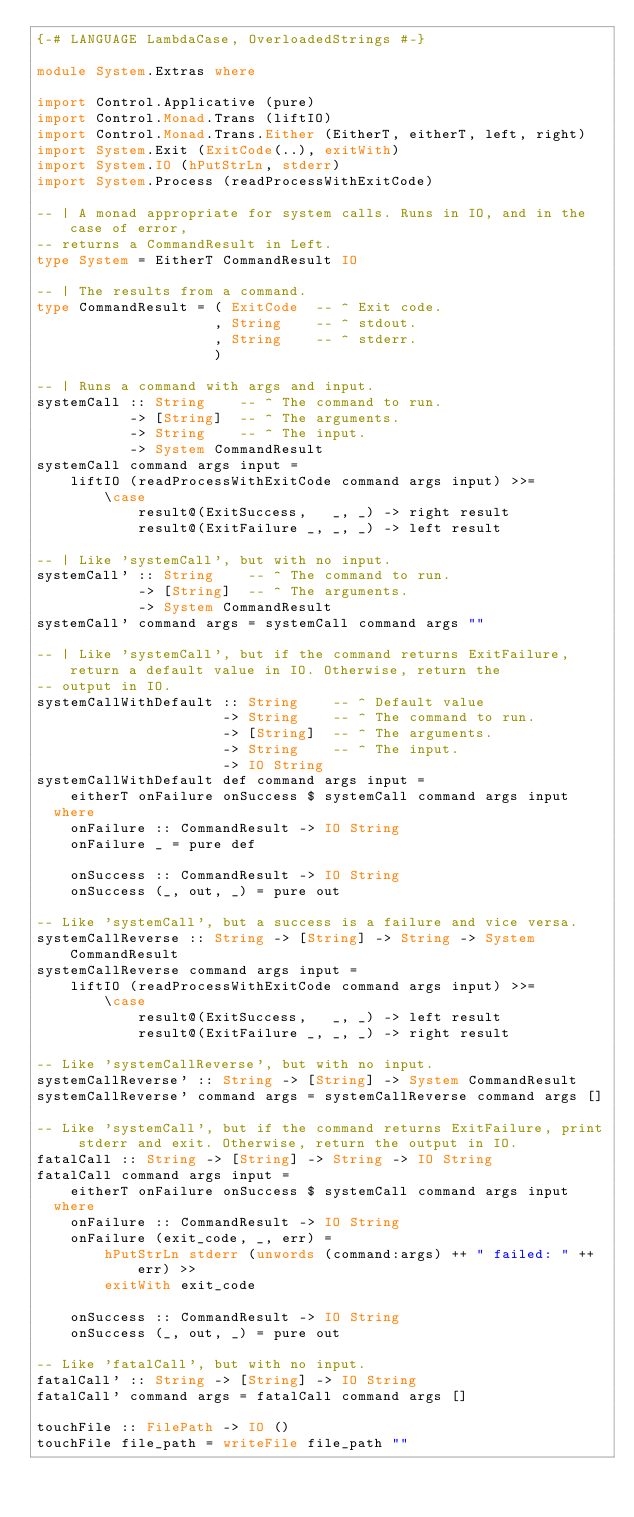<code> <loc_0><loc_0><loc_500><loc_500><_Haskell_>{-# LANGUAGE LambdaCase, OverloadedStrings #-}

module System.Extras where

import Control.Applicative (pure)
import Control.Monad.Trans (liftIO)
import Control.Monad.Trans.Either (EitherT, eitherT, left, right)
import System.Exit (ExitCode(..), exitWith)
import System.IO (hPutStrLn, stderr)
import System.Process (readProcessWithExitCode)

-- | A monad appropriate for system calls. Runs in IO, and in the case of error,
-- returns a CommandResult in Left.
type System = EitherT CommandResult IO

-- | The results from a command.
type CommandResult = ( ExitCode  -- ^ Exit code.
                     , String    -- ^ stdout.
                     , String    -- ^ stderr.
                     )

-- | Runs a command with args and input.
systemCall :: String    -- ^ The command to run.
           -> [String]  -- ^ The arguments.
           -> String    -- ^ The input.
           -> System CommandResult
systemCall command args input =
    liftIO (readProcessWithExitCode command args input) >>=
        \case
            result@(ExitSuccess,   _, _) -> right result
            result@(ExitFailure _, _, _) -> left result

-- | Like 'systemCall', but with no input.
systemCall' :: String    -- ^ The command to run.
            -> [String]  -- ^ The arguments.
            -> System CommandResult
systemCall' command args = systemCall command args ""

-- | Like 'systemCall', but if the command returns ExitFailure, return a default value in IO. Otherwise, return the
-- output in IO.
systemCallWithDefault :: String    -- ^ Default value
                      -> String    -- ^ The command to run.
                      -> [String]  -- ^ The arguments.
                      -> String    -- ^ The input.
                      -> IO String
systemCallWithDefault def command args input =
    eitherT onFailure onSuccess $ systemCall command args input
  where
    onFailure :: CommandResult -> IO String
    onFailure _ = pure def

    onSuccess :: CommandResult -> IO String
    onSuccess (_, out, _) = pure out

-- Like 'systemCall', but a success is a failure and vice versa.
systemCallReverse :: String -> [String] -> String -> System CommandResult
systemCallReverse command args input =
    liftIO (readProcessWithExitCode command args input) >>=
        \case
            result@(ExitSuccess,   _, _) -> left result
            result@(ExitFailure _, _, _) -> right result

-- Like 'systemCallReverse', but with no input.
systemCallReverse' :: String -> [String] -> System CommandResult
systemCallReverse' command args = systemCallReverse command args []

-- Like 'systemCall', but if the command returns ExitFailure, print stderr and exit. Otherwise, return the output in IO.
fatalCall :: String -> [String] -> String -> IO String
fatalCall command args input =
    eitherT onFailure onSuccess $ systemCall command args input
  where
    onFailure :: CommandResult -> IO String
    onFailure (exit_code, _, err) =
        hPutStrLn stderr (unwords (command:args) ++ " failed: " ++ err) >>
        exitWith exit_code

    onSuccess :: CommandResult -> IO String
    onSuccess (_, out, _) = pure out

-- Like 'fatalCall', but with no input.
fatalCall' :: String -> [String] -> IO String
fatalCall' command args = fatalCall command args []

touchFile :: FilePath -> IO ()
touchFile file_path = writeFile file_path ""
</code> 